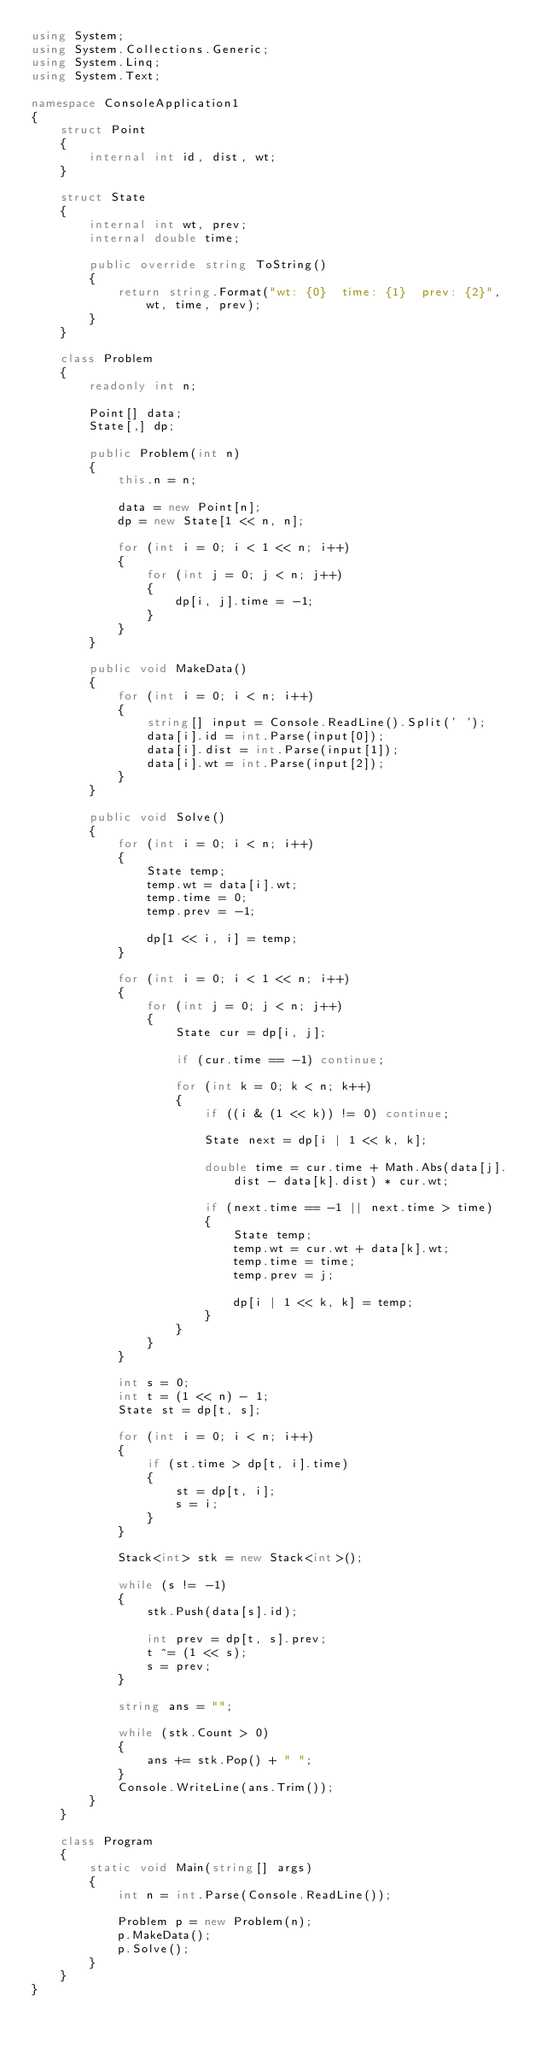Convert code to text. <code><loc_0><loc_0><loc_500><loc_500><_C#_>using System;
using System.Collections.Generic;
using System.Linq;
using System.Text;

namespace ConsoleApplication1
{
    struct Point
    {
        internal int id, dist, wt;
    }

    struct State
    {
        internal int wt, prev;
        internal double time;

        public override string ToString()
        {
            return string.Format("wt: {0}  time: {1}  prev: {2}", wt, time, prev);
        }
    }

    class Problem
    {
        readonly int n;

        Point[] data;
        State[,] dp;

        public Problem(int n)
        {
            this.n = n;

            data = new Point[n];
            dp = new State[1 << n, n];

            for (int i = 0; i < 1 << n; i++)
            {
                for (int j = 0; j < n; j++)
                {
                    dp[i, j].time = -1;
                }
            }
        }

        public void MakeData()
        {
            for (int i = 0; i < n; i++)
            {
                string[] input = Console.ReadLine().Split(' ');
                data[i].id = int.Parse(input[0]);
                data[i].dist = int.Parse(input[1]);
                data[i].wt = int.Parse(input[2]);
            }
        }

        public void Solve()
        {
            for (int i = 0; i < n; i++)
            {
                State temp;
                temp.wt = data[i].wt;
                temp.time = 0;
                temp.prev = -1;

                dp[1 << i, i] = temp;
            }

            for (int i = 0; i < 1 << n; i++)
            {
                for (int j = 0; j < n; j++)
                {
                    State cur = dp[i, j];

                    if (cur.time == -1) continue;

                    for (int k = 0; k < n; k++)
                    {
                        if ((i & (1 << k)) != 0) continue;

                        State next = dp[i | 1 << k, k];

                        double time = cur.time + Math.Abs(data[j].dist - data[k].dist) * cur.wt;

                        if (next.time == -1 || next.time > time)
                        {
                            State temp;
                            temp.wt = cur.wt + data[k].wt;
                            temp.time = time;
                            temp.prev = j;

                            dp[i | 1 << k, k] = temp;
                        }
                    }
                }
            }

            int s = 0;
            int t = (1 << n) - 1;
            State st = dp[t, s];

            for (int i = 0; i < n; i++)
            {
                if (st.time > dp[t, i].time)
                {
                    st = dp[t, i];
                    s = i;
                }
            }

            Stack<int> stk = new Stack<int>();

            while (s != -1)
            {
                stk.Push(data[s].id);

                int prev = dp[t, s].prev;
                t ^= (1 << s);
                s = prev;
            }

            string ans = "";

            while (stk.Count > 0)
            {
                ans += stk.Pop() + " ";
            }
            Console.WriteLine(ans.Trim());
        }
    }

    class Program
    {
        static void Main(string[] args)
        {
            int n = int.Parse(Console.ReadLine());

            Problem p = new Problem(n);
            p.MakeData();
            p.Solve();
        }
    }
}</code> 